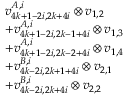<formula> <loc_0><loc_0><loc_500><loc_500>\begin{array} { r l } & { v _ { 4 k + 1 - 2 i , 2 k + 4 i } ^ { A , i } \otimes v _ { 1 , 2 } } \\ & { + v _ { 4 k + 1 - 2 i , 2 k - 1 + 4 i } ^ { A , i } \otimes v _ { 1 , 3 } } \\ & { + v _ { 4 k + 1 - 2 i , 2 k - 2 + 4 i } ^ { A , i } \otimes v _ { 1 , 4 } } \\ & { + v _ { 4 k - 2 i , 2 k + 1 + 4 i } ^ { B , i } \otimes v _ { 2 , 1 } } \\ & { + v _ { 4 k - 2 i , 2 k + 4 i } ^ { B , i } \otimes v _ { 2 , 2 } } \end{array}</formula> 